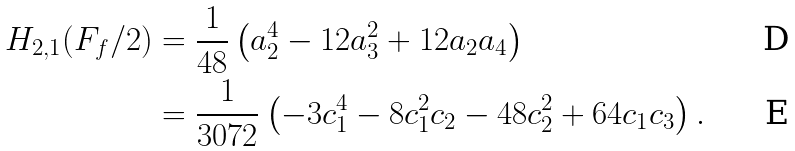<formula> <loc_0><loc_0><loc_500><loc_500>H _ { 2 , 1 } ( F _ { f } / 2 ) & = \frac { 1 } { 4 8 } \left ( a ^ { 4 } _ { 2 } - 1 2 a ^ { 2 } _ { 3 } + 1 2 a _ { 2 } a _ { 4 } \right ) \\ & = \frac { 1 } { 3 0 7 2 } \left ( - 3 c ^ { 4 } _ { 1 } - 8 c ^ { 2 } _ { 1 } c _ { 2 } - 4 8 c ^ { 2 } _ { 2 } + 6 4 c _ { 1 } c _ { 3 } \right ) .</formula> 